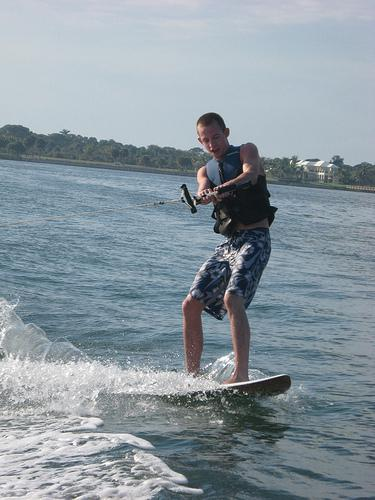Question: what sport is this?
Choices:
A. Baseball.
B. Softball.
C. Football.
D. Wakeboarding.
Answer with the letter. Answer: D Question: where on this person's body is the board?
Choices:
A. Hands.
B. Feet.
C. Butt.
D. Head.
Answer with the letter. Answer: B Question: what is he wearing on his torso?
Choices:
A. T-shirt.
B. Jacket.
C. Life jacket.
D. Windbreaker.
Answer with the letter. Answer: C Question: what kind of surface is he traveling across?
Choices:
A. Water.
B. Grass.
C. Concrete.
D. Highway.
Answer with the letter. Answer: A Question: what kind of shorts is he wearing?
Choices:
A. Swim trunks.
B. Gym shorts.
C. Cargo shorts.
D. Short shorts.
Answer with the letter. Answer: A Question: what direction is the person traveling in relation to the viewer?
Choices:
A. Left.
B. Backwards.
C. Right.
D. Forwards.
Answer with the letter. Answer: C Question: what is being used to tow this person?
Choices:
A. Rope.
B. Cable.
C. Tow truck.
D. Speed boat.
Answer with the letter. Answer: B 